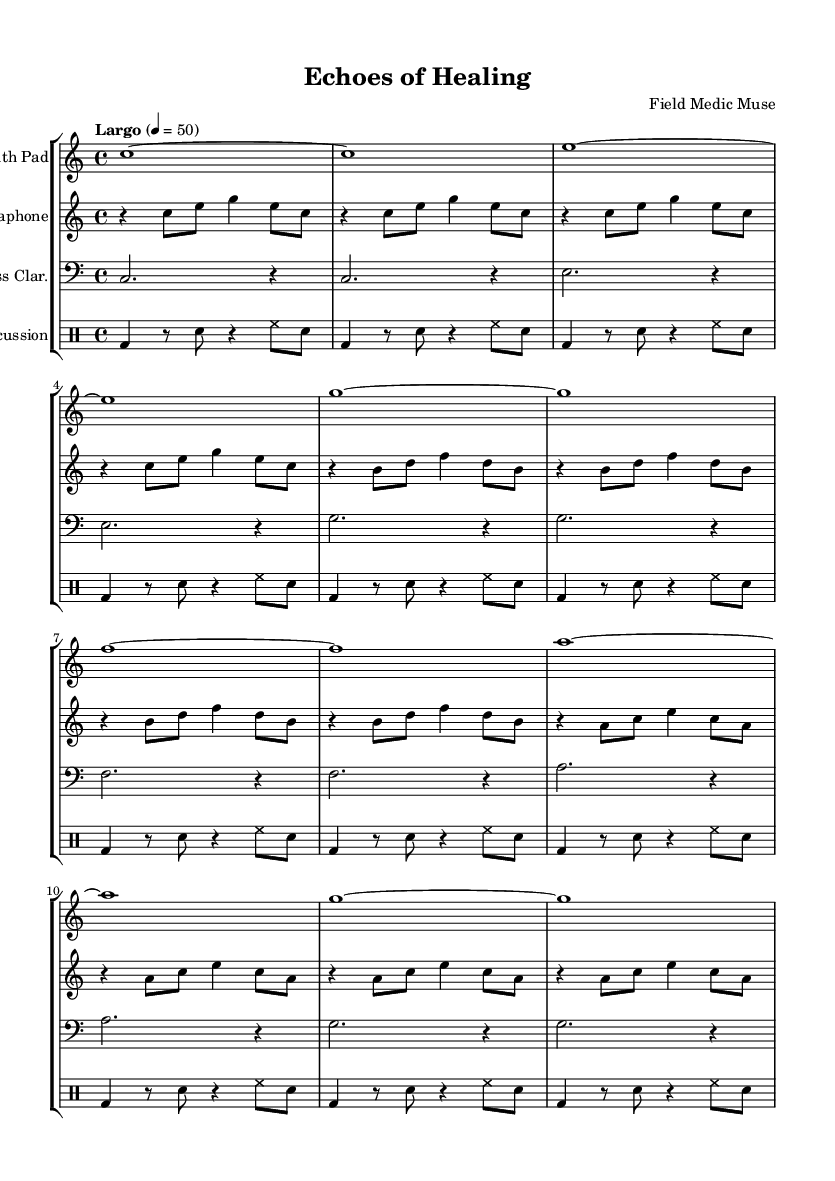What is the key signature of this music? The key signature is indicated before the time signature at the beginning of the sheet music. It shows there are no sharps or flats, which defines C major.
Answer: C major What is the time signature of this music? The time signature is typically placed just after the key signature at the beginning of the sheet. The "4/4" indicates four beats per measure with a quarter note getting one beat.
Answer: 4/4 What is the tempo marking for this music? The tempo is indicated with a marking in Italian at the start, stating "Largo." A number follows it, indicating the beats per minute as 50.
Answer: Largo How many measures are in Theme A for the synth pad? The sheet music shows that Theme A consists of 4 measures for the synth pad, as it is explicitly stated within the music line.
Answer: 4 measures What instrument is playing the lowest voice? The bass clarinet is specifically noted to be in the bass clef, indicating it plays the lowest voice in this composition.
Answer: Bass Clarinet How many times is the percussion pattern repeated? The percussion section has a repeating pattern indicated by the "unfold" command and is noted to repeat 8 times first and then 4 times for the subsequent theme.
Answer: 8 and 4 times What is the main inspiration for this piece? The title "Echoes of Healing" suggests a specific theme related to hospital environments and medical experiences, which implies that the piece is inspired by these settings.
Answer: Hospital environments 